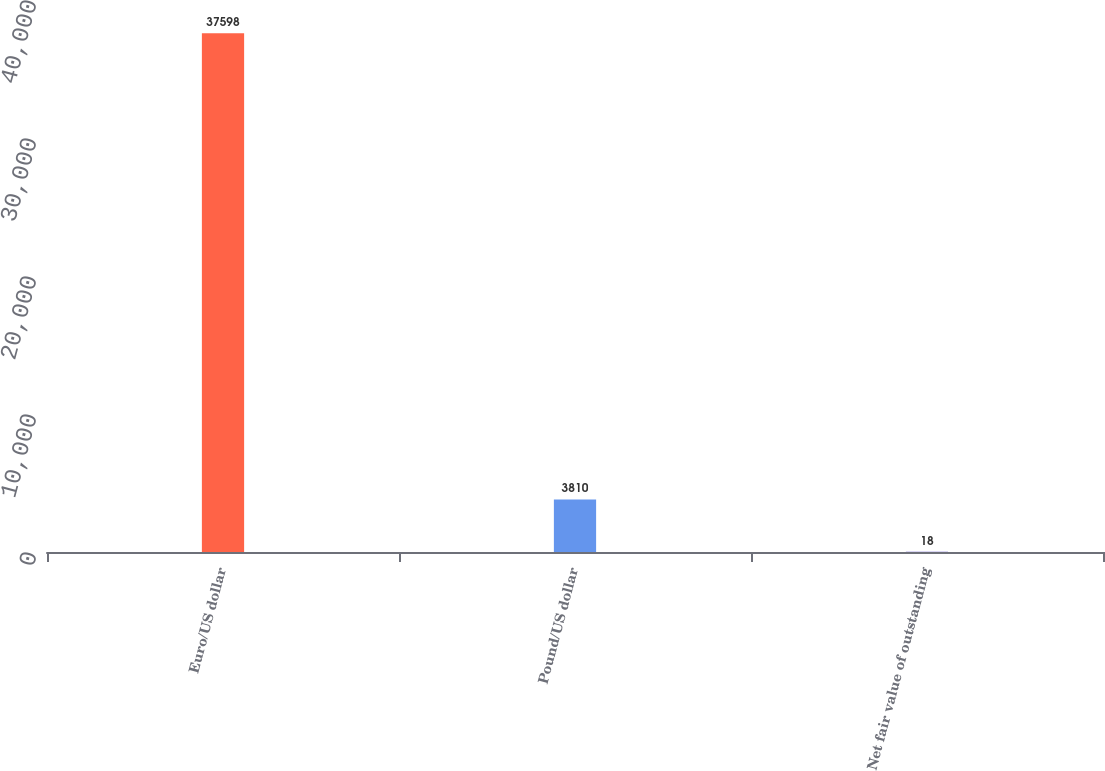<chart> <loc_0><loc_0><loc_500><loc_500><bar_chart><fcel>Euro/US dollar<fcel>Pound/US dollar<fcel>Net fair value of outstanding<nl><fcel>37598<fcel>3810<fcel>18<nl></chart> 